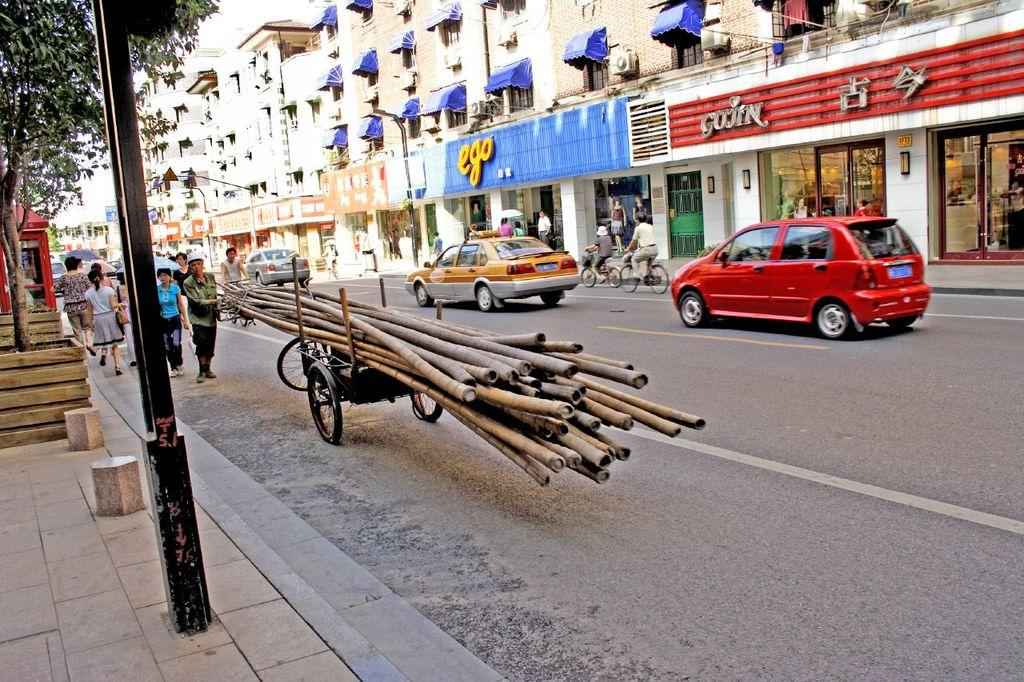<image>
Write a terse but informative summary of the picture. A store called Ego has a blue storefront. 